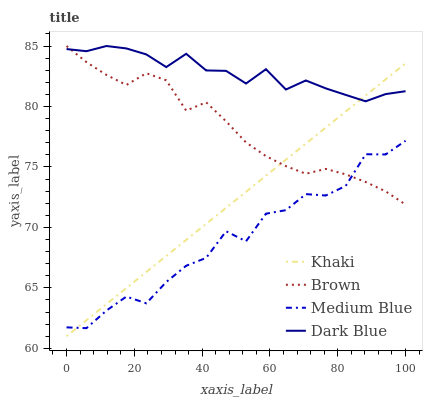Does Medium Blue have the minimum area under the curve?
Answer yes or no. Yes. Does Dark Blue have the maximum area under the curve?
Answer yes or no. Yes. Does Khaki have the minimum area under the curve?
Answer yes or no. No. Does Khaki have the maximum area under the curve?
Answer yes or no. No. Is Khaki the smoothest?
Answer yes or no. Yes. Is Medium Blue the roughest?
Answer yes or no. Yes. Is Medium Blue the smoothest?
Answer yes or no. No. Is Khaki the roughest?
Answer yes or no. No. Does Khaki have the lowest value?
Answer yes or no. Yes. Does Medium Blue have the lowest value?
Answer yes or no. No. Does Dark Blue have the highest value?
Answer yes or no. Yes. Does Khaki have the highest value?
Answer yes or no. No. Is Medium Blue less than Dark Blue?
Answer yes or no. Yes. Is Dark Blue greater than Medium Blue?
Answer yes or no. Yes. Does Dark Blue intersect Brown?
Answer yes or no. Yes. Is Dark Blue less than Brown?
Answer yes or no. No. Is Dark Blue greater than Brown?
Answer yes or no. No. Does Medium Blue intersect Dark Blue?
Answer yes or no. No. 